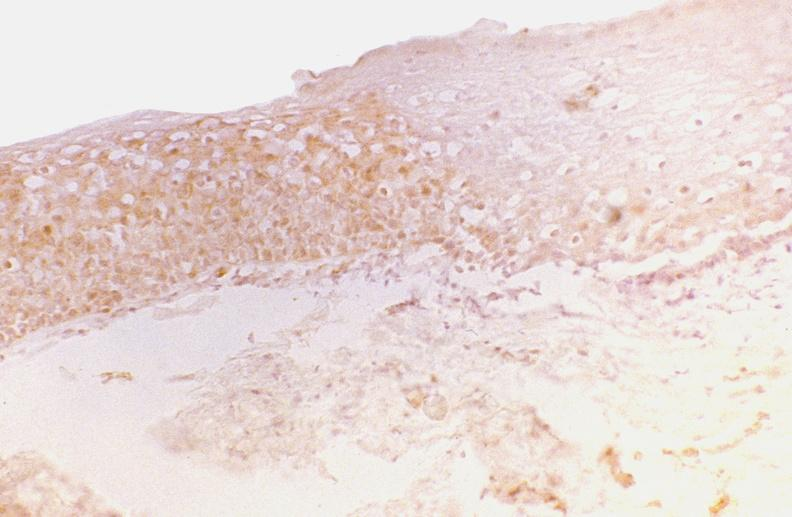does supernumerary digits show oral dysplasia, tgf-gamma?
Answer the question using a single word or phrase. No 